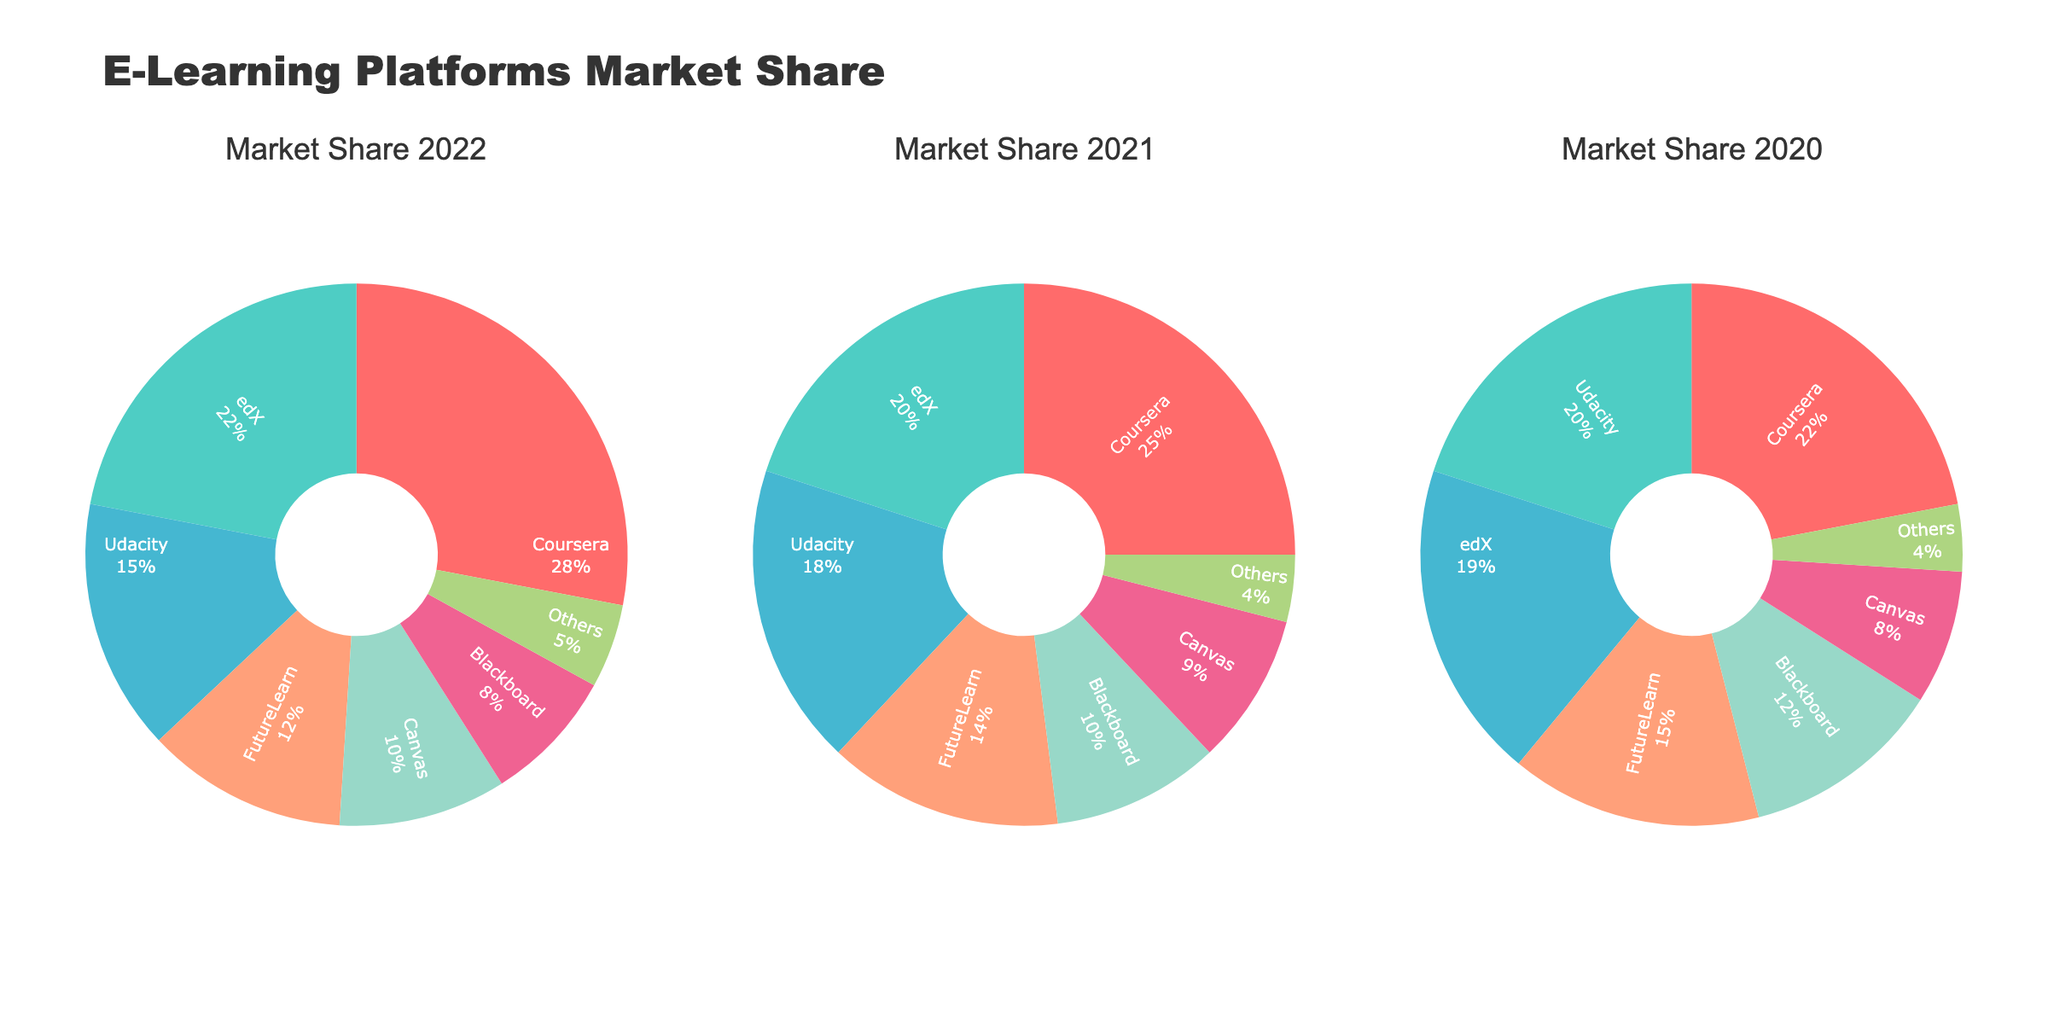what is the title of the figure? The title of the figure is usually displayed at the top of the scatter plot matrix. By reading it directly, one can identify the given title.
Answer: Consumer Demographics and Behavior Matrix How many variables are compared in this scatterplot matrix? Each dimension represents a variable in the dataset. By counting them from the axis labels, you can determine the number of variables being compared.
Answer: 5 variables Which age group shows the highest range of income based on the scatterplot matrix? By examining the scatterplot cells involving the 'Age' and 'Income' variables, you can determine that older age groups appear to have a wider range and higher values of income. Specifically, older individuals like those in their 50s display the highest variation.
Answer: 50s Is there a visible trend between 'Income' and 'OnlineSpending'? Looking at the scatterplot cell where 'Income' and 'OnlineSpending' are plotted against each other, observe if a pattern or linear trend is visible. In this case, there is a positive association visible.
Answer: Yes, positive trend Which variable appears to have the weakest correlation with 'Social Media Usage'? By examining the scatterplot cells involving 'Social Media Usage' and the other variables, identify which one lacks a clear pattern or trend. 'Income' and 'Social Media Usage' seem to show the weakest correlation as no clear trend is visible.
Answer: Income Which variable seems to have the strongest correlation with 'Age'? By observing the scatterplot matrix cells where 'Age' is compared with other variables, identify the one that shows a clear linear pattern or trend. The cell with 'Income' against 'Age' shows a visible positive linear relationship.
Answer: Income What is the average 'Brand Loyalty' score for individuals aged between 40 and 50 years? Identify the data points within the Age range 40 to 50 in the scatterplot cell representing 'Age' vs. 'BrandLoyalty.' Sum their 'BrandLoyalty' scores and divide by the number of data points to find the average. The values are 8.3, 8.5, 8.7, 8.2, resulting in an average of (8.3+8.5+8.7+8.2)/4 = 8.425.
Answer: 8.425 Is there a significant variation in 'OnlineSpending' among different 'Age' groups? Observing the scatterplots where 'Age' is plotted against 'OnlineSpending,' recognize the dispersion of data points along the 'OnlineSpending' axis for different age categories. There is noticeable variation in the amount spent across various age groups.
Answer: Yes Which data point has the maximum 'OnlineSpending'? Look at the 'OnlineSpending' variable's plotted scatterplots to find the data point farthest towards the top of the axis. The maximum 'OnlineSpending' observed is $5900.
Answer: $5900 